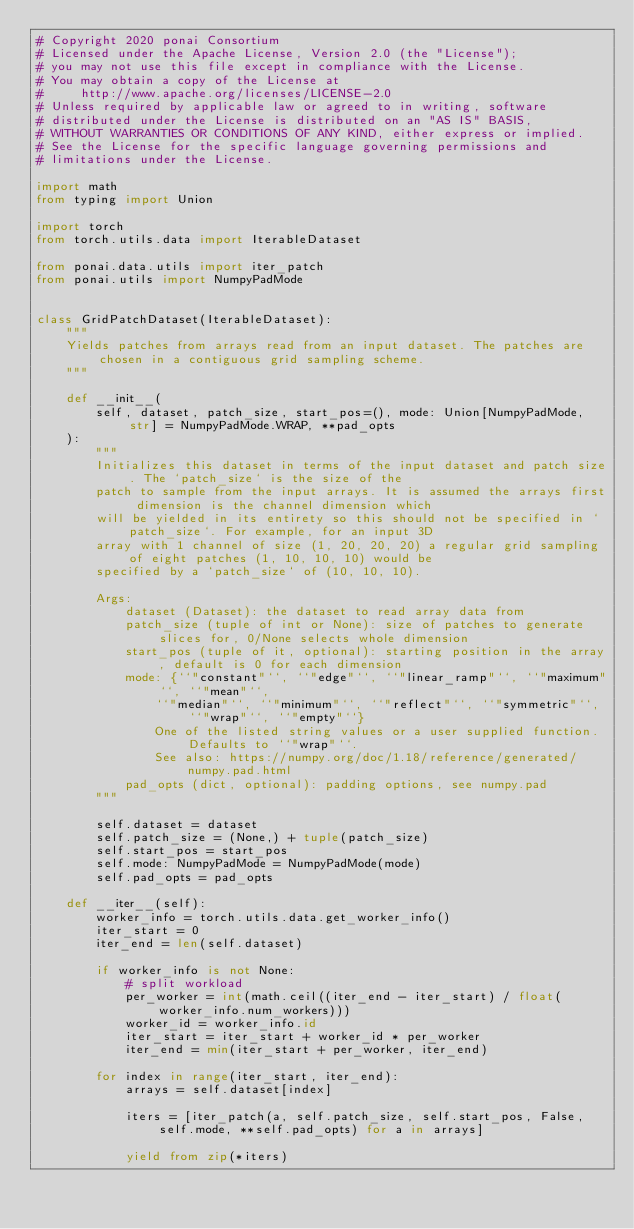Convert code to text. <code><loc_0><loc_0><loc_500><loc_500><_Python_># Copyright 2020 ponai Consortium
# Licensed under the Apache License, Version 2.0 (the "License");
# you may not use this file except in compliance with the License.
# You may obtain a copy of the License at
#     http://www.apache.org/licenses/LICENSE-2.0
# Unless required by applicable law or agreed to in writing, software
# distributed under the License is distributed on an "AS IS" BASIS,
# WITHOUT WARRANTIES OR CONDITIONS OF ANY KIND, either express or implied.
# See the License for the specific language governing permissions and
# limitations under the License.

import math
from typing import Union

import torch
from torch.utils.data import IterableDataset

from ponai.data.utils import iter_patch
from ponai.utils import NumpyPadMode


class GridPatchDataset(IterableDataset):
    """
    Yields patches from arrays read from an input dataset. The patches are chosen in a contiguous grid sampling scheme.
    """

    def __init__(
        self, dataset, patch_size, start_pos=(), mode: Union[NumpyPadMode, str] = NumpyPadMode.WRAP, **pad_opts
    ):
        """
        Initializes this dataset in terms of the input dataset and patch size. The `patch_size` is the size of the
        patch to sample from the input arrays. It is assumed the arrays first dimension is the channel dimension which
        will be yielded in its entirety so this should not be specified in `patch_size`. For example, for an input 3D
        array with 1 channel of size (1, 20, 20, 20) a regular grid sampling of eight patches (1, 10, 10, 10) would be
        specified by a `patch_size` of (10, 10, 10).

        Args:
            dataset (Dataset): the dataset to read array data from
            patch_size (tuple of int or None): size of patches to generate slices for, 0/None selects whole dimension
            start_pos (tuple of it, optional): starting position in the array, default is 0 for each dimension
            mode: {``"constant"``, ``"edge"``, ``"linear_ramp"``, ``"maximum"``, ``"mean"``,
                ``"median"``, ``"minimum"``, ``"reflect"``, ``"symmetric"``, ``"wrap"``, ``"empty"``}
                One of the listed string values or a user supplied function. Defaults to ``"wrap"``.
                See also: https://numpy.org/doc/1.18/reference/generated/numpy.pad.html
            pad_opts (dict, optional): padding options, see numpy.pad
        """

        self.dataset = dataset
        self.patch_size = (None,) + tuple(patch_size)
        self.start_pos = start_pos
        self.mode: NumpyPadMode = NumpyPadMode(mode)
        self.pad_opts = pad_opts

    def __iter__(self):
        worker_info = torch.utils.data.get_worker_info()
        iter_start = 0
        iter_end = len(self.dataset)

        if worker_info is not None:
            # split workload
            per_worker = int(math.ceil((iter_end - iter_start) / float(worker_info.num_workers)))
            worker_id = worker_info.id
            iter_start = iter_start + worker_id * per_worker
            iter_end = min(iter_start + per_worker, iter_end)

        for index in range(iter_start, iter_end):
            arrays = self.dataset[index]

            iters = [iter_patch(a, self.patch_size, self.start_pos, False, self.mode, **self.pad_opts) for a in arrays]

            yield from zip(*iters)
</code> 